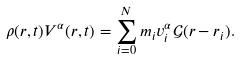Convert formula to latex. <formula><loc_0><loc_0><loc_500><loc_500>\rho ( { r } , t ) V ^ { \alpha } ( { r } , t ) = \sum _ { i = 0 } ^ { N } m _ { i } v _ { i } ^ { \alpha } \mathcal { G } ( { r } - { r _ { i } } ) .</formula> 